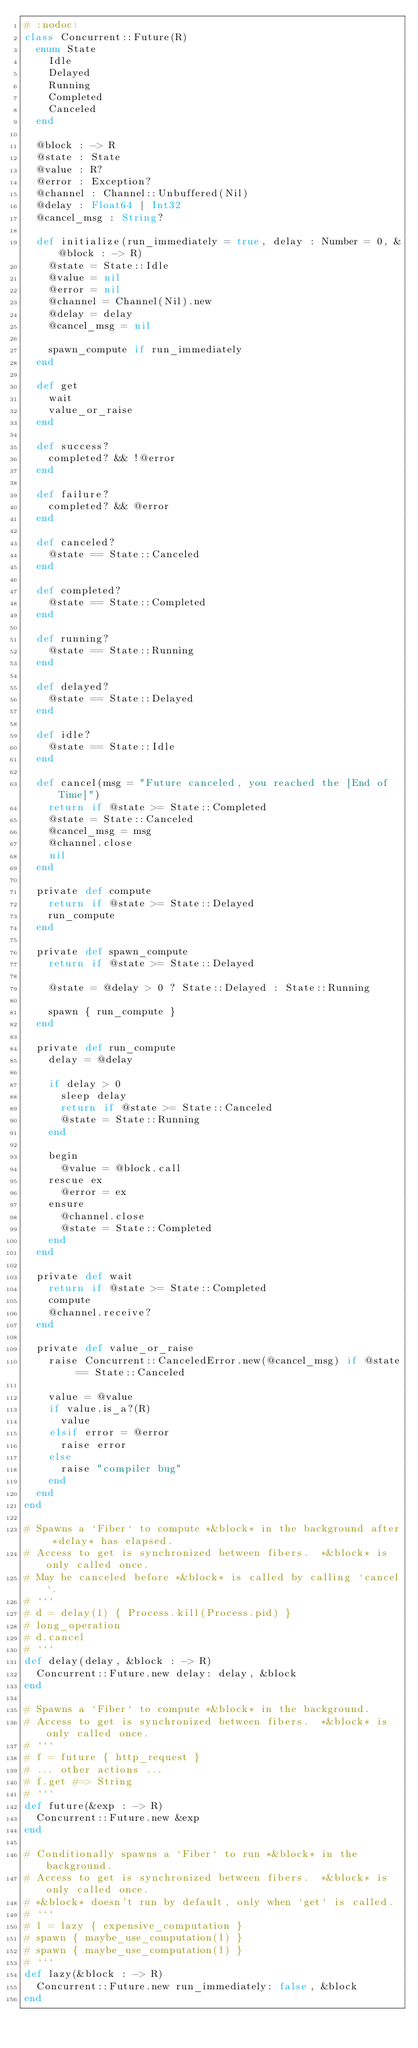Convert code to text. <code><loc_0><loc_0><loc_500><loc_500><_Crystal_># :nodoc:
class Concurrent::Future(R)
  enum State
    Idle
    Delayed
    Running
    Completed
    Canceled
  end

  @block : -> R
  @state : State
  @value : R?
  @error : Exception?
  @channel : Channel::Unbuffered(Nil)
  @delay : Float64 | Int32
  @cancel_msg : String?

  def initialize(run_immediately = true, delay : Number = 0, &@block : -> R)
    @state = State::Idle
    @value = nil
    @error = nil
    @channel = Channel(Nil).new
    @delay = delay
    @cancel_msg = nil

    spawn_compute if run_immediately
  end

  def get
    wait
    value_or_raise
  end

  def success?
    completed? && !@error
  end

  def failure?
    completed? && @error
  end

  def canceled?
    @state == State::Canceled
  end

  def completed?
    @state == State::Completed
  end

  def running?
    @state == State::Running
  end

  def delayed?
    @state == State::Delayed
  end

  def idle?
    @state == State::Idle
  end

  def cancel(msg = "Future canceled, you reached the [End of Time]")
    return if @state >= State::Completed
    @state = State::Canceled
    @cancel_msg = msg
    @channel.close
    nil
  end

  private def compute
    return if @state >= State::Delayed
    run_compute
  end

  private def spawn_compute
    return if @state >= State::Delayed

    @state = @delay > 0 ? State::Delayed : State::Running

    spawn { run_compute }
  end

  private def run_compute
    delay = @delay

    if delay > 0
      sleep delay
      return if @state >= State::Canceled
      @state = State::Running
    end

    begin
      @value = @block.call
    rescue ex
      @error = ex
    ensure
      @channel.close
      @state = State::Completed
    end
  end

  private def wait
    return if @state >= State::Completed
    compute
    @channel.receive?
  end

  private def value_or_raise
    raise Concurrent::CanceledError.new(@cancel_msg) if @state == State::Canceled

    value = @value
    if value.is_a?(R)
      value
    elsif error = @error
      raise error
    else
      raise "compiler bug"
    end
  end
end

# Spawns a `Fiber` to compute *&block* in the background after *delay* has elapsed.
# Access to get is synchronized between fibers.  *&block* is only called once.
# May be canceled before *&block* is called by calling `cancel`.
# ```
# d = delay(1) { Process.kill(Process.pid) }
# long_operation
# d.cancel
# ```
def delay(delay, &block : -> R)
  Concurrent::Future.new delay: delay, &block
end

# Spawns a `Fiber` to compute *&block* in the background.
# Access to get is synchronized between fibers.  *&block* is only called once.
# ```
# f = future { http_request }
# ... other actions ...
# f.get #=> String
# ```
def future(&exp : -> R)
  Concurrent::Future.new &exp
end

# Conditionally spawns a `Fiber` to run *&block* in the background.
# Access to get is synchronized between fibers.  *&block* is only called once.
# *&block* doesn't run by default, only when `get` is called.
# ```
# l = lazy { expensive_computation }
# spawn { maybe_use_computation(l) }
# spawn { maybe_use_computation(l) }
# ```
def lazy(&block : -> R)
  Concurrent::Future.new run_immediately: false, &block
end
</code> 